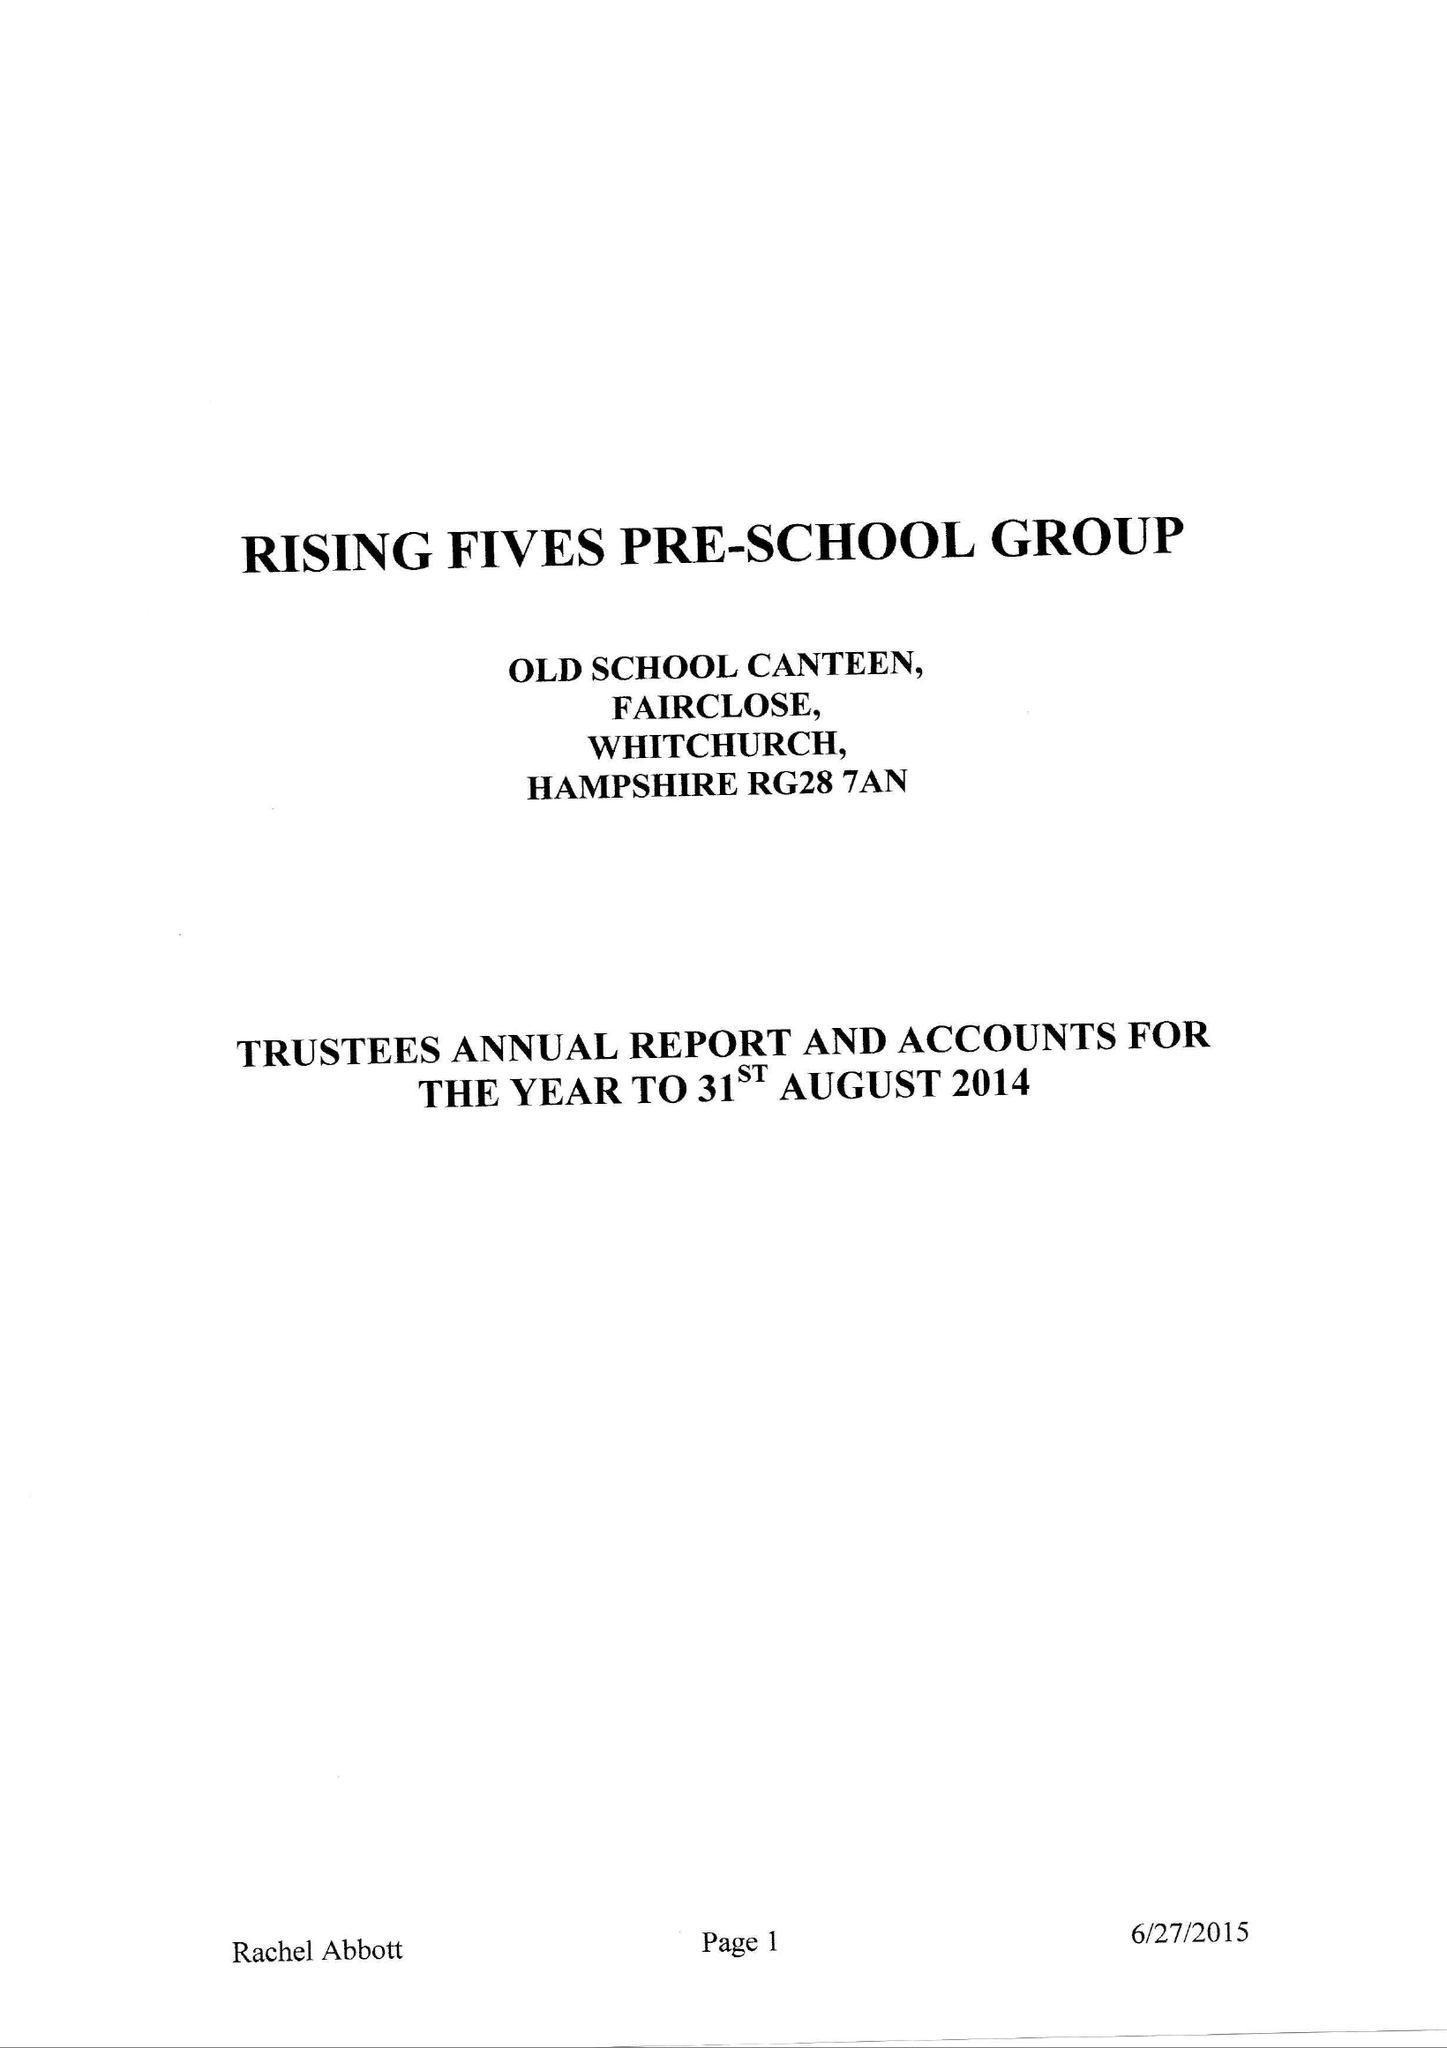What is the value for the report_date?
Answer the question using a single word or phrase. 2014-08-31 